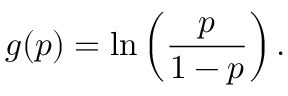Convert formula to latex. <formula><loc_0><loc_0><loc_500><loc_500>g ( p ) = \ln \left ( { \frac { p } { 1 - p } } \right ) .</formula> 